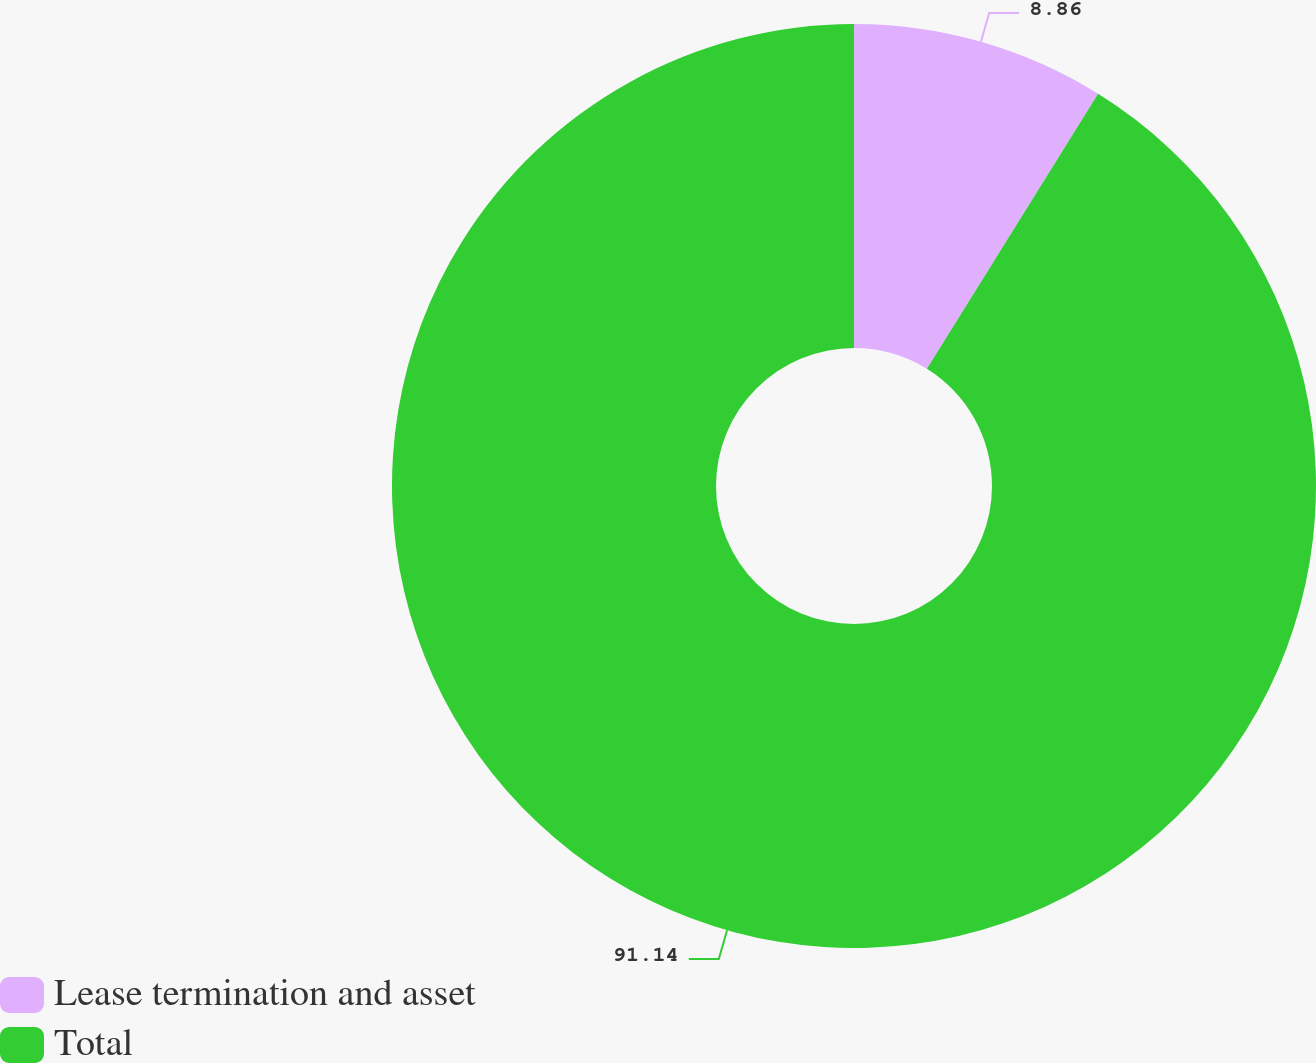Convert chart. <chart><loc_0><loc_0><loc_500><loc_500><pie_chart><fcel>Lease termination and asset<fcel>Total<nl><fcel>8.86%<fcel>91.14%<nl></chart> 